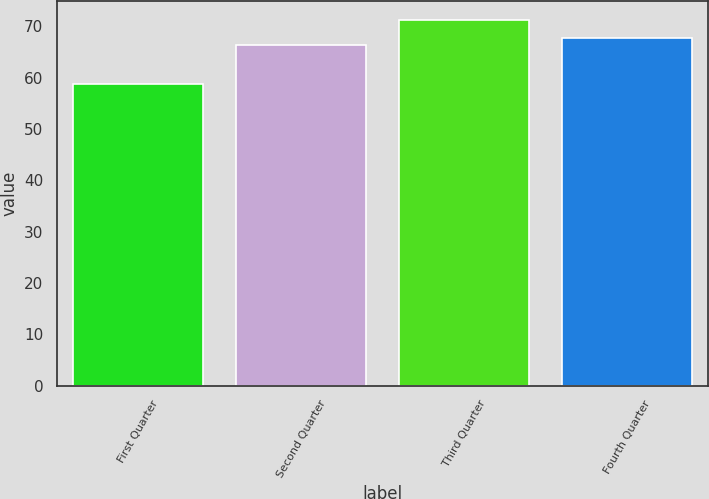Convert chart. <chart><loc_0><loc_0><loc_500><loc_500><bar_chart><fcel>First Quarter<fcel>Second Quarter<fcel>Third Quarter<fcel>Fourth Quarter<nl><fcel>58.85<fcel>66.47<fcel>71.32<fcel>67.72<nl></chart> 